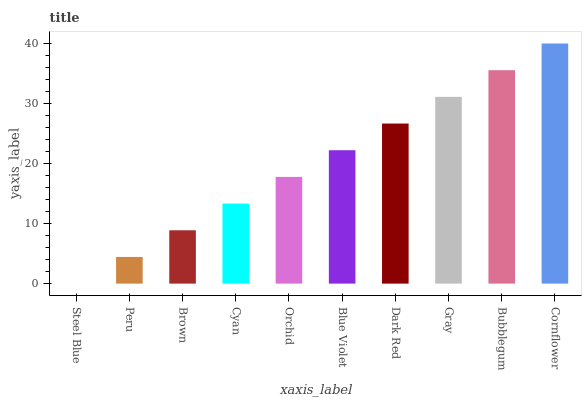Is Steel Blue the minimum?
Answer yes or no. Yes. Is Cornflower the maximum?
Answer yes or no. Yes. Is Peru the minimum?
Answer yes or no. No. Is Peru the maximum?
Answer yes or no. No. Is Peru greater than Steel Blue?
Answer yes or no. Yes. Is Steel Blue less than Peru?
Answer yes or no. Yes. Is Steel Blue greater than Peru?
Answer yes or no. No. Is Peru less than Steel Blue?
Answer yes or no. No. Is Blue Violet the high median?
Answer yes or no. Yes. Is Orchid the low median?
Answer yes or no. Yes. Is Cornflower the high median?
Answer yes or no. No. Is Bubblegum the low median?
Answer yes or no. No. 